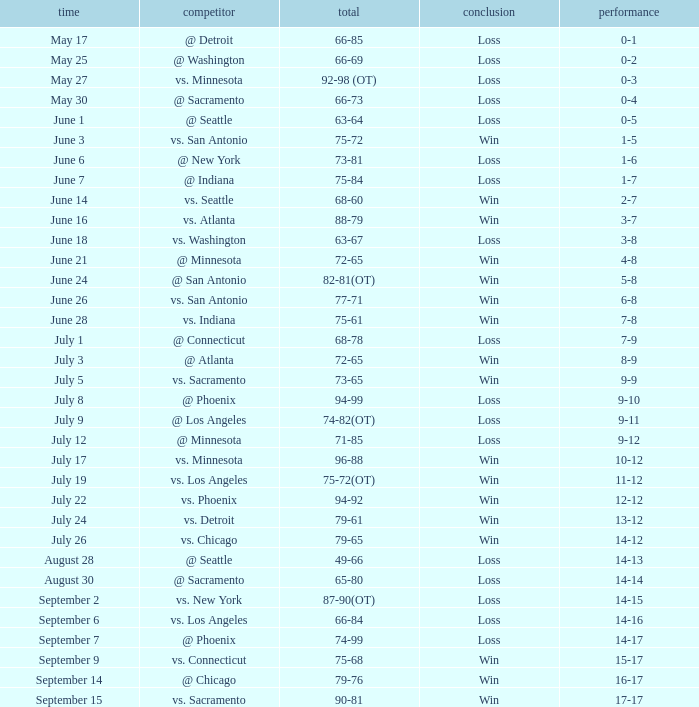What is the Record of the game on June 24? 5-8. 